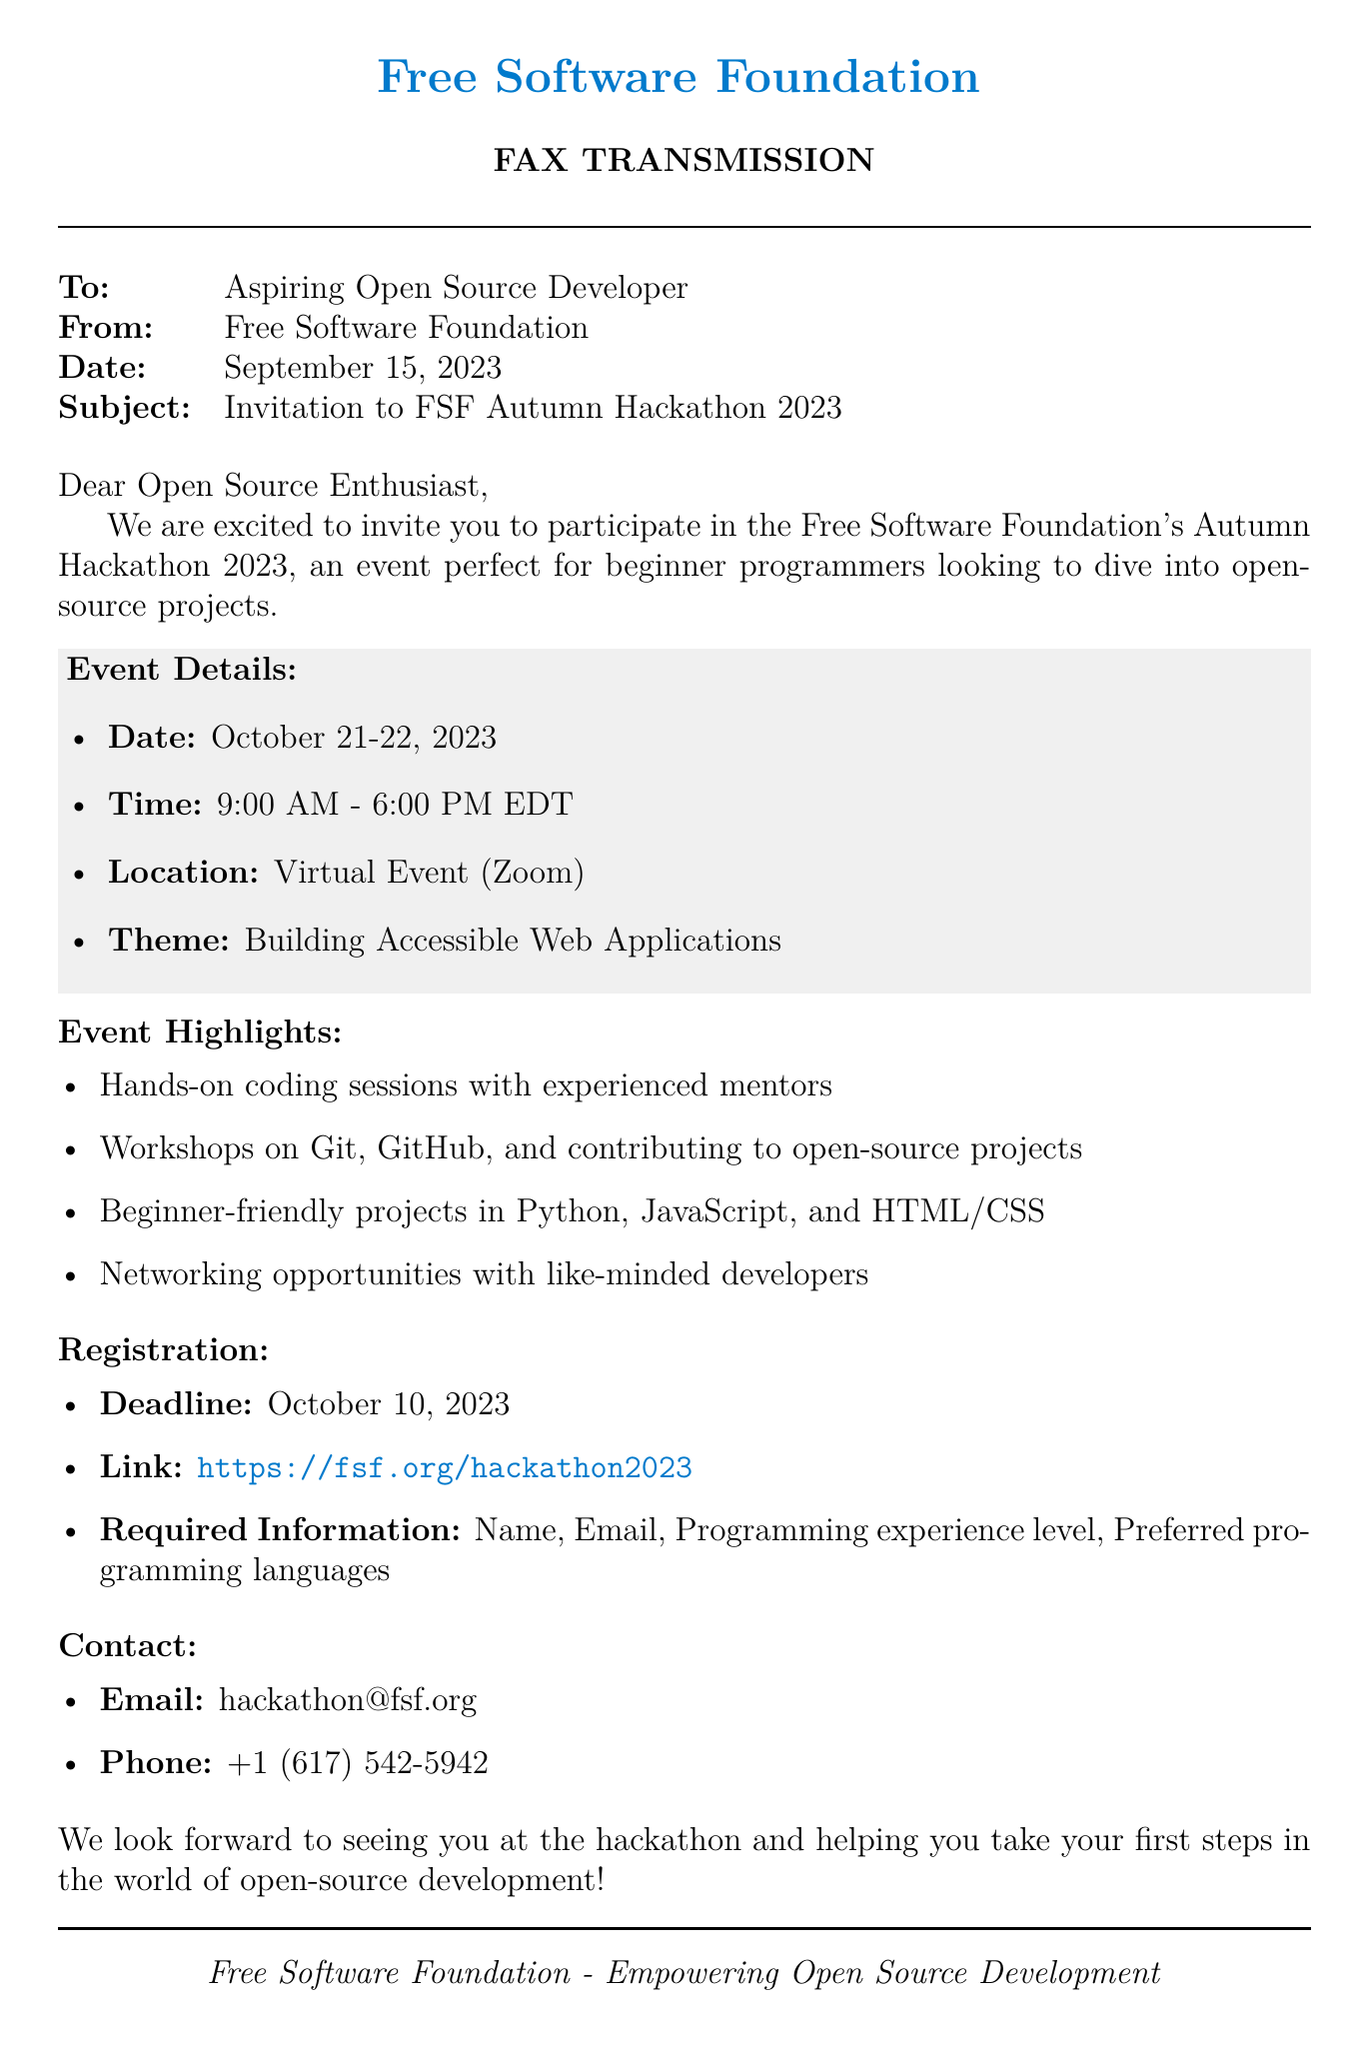What is the date of the hackathon? The hackathon is scheduled for October 21-22, 2023, as mentioned in the event details section.
Answer: October 21-22, 2023 What is the theme of the hackathon? The theme is specified in the event details section of the document.
Answer: Building Accessible Web Applications What is the registration deadline? The deadline for registration is clearly stated in the registration section of the document.
Answer: October 10, 2023 What is the contact email for the event? The contact email is listed under the contact section in the document.
Answer: hackathon@fsf.org What are the event's operating hours? The operating hours are detailed in the event details section, indicating when the event will take place.
Answer: 9:00 AM - 6:00 PM EDT Which programming languages are mentioned for beginner-friendly projects? The programming languages are specified in the event highlights section of the document.
Answer: Python, JavaScript, and HTML/CSS What type of event is this? The document explicitly states the nature of the event at the beginning.
Answer: Virtual Event What kind of sessions will be provided at the event? The types of sessions are described in the event highlights section, suggesting the format of the event.
Answer: Hands-on coding sessions with experienced mentors How can participants register for the event? The registration process is detailed in the registration section, including where to go to sign up.
Answer: https://fsf.org/hackathon2023 